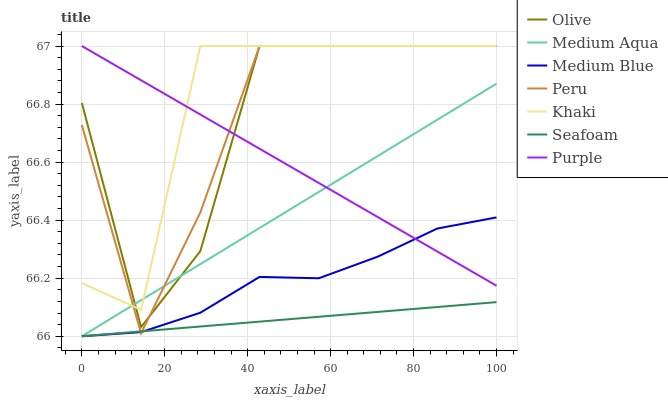Does Seafoam have the minimum area under the curve?
Answer yes or no. Yes. Does Khaki have the maximum area under the curve?
Answer yes or no. Yes. Does Purple have the minimum area under the curve?
Answer yes or no. No. Does Purple have the maximum area under the curve?
Answer yes or no. No. Is Seafoam the smoothest?
Answer yes or no. Yes. Is Olive the roughest?
Answer yes or no. Yes. Is Purple the smoothest?
Answer yes or no. No. Is Purple the roughest?
Answer yes or no. No. Does Medium Blue have the lowest value?
Answer yes or no. Yes. Does Purple have the lowest value?
Answer yes or no. No. Does Olive have the highest value?
Answer yes or no. Yes. Does Medium Blue have the highest value?
Answer yes or no. No. Is Medium Blue less than Khaki?
Answer yes or no. Yes. Is Olive greater than Medium Blue?
Answer yes or no. Yes. Does Medium Aqua intersect Olive?
Answer yes or no. Yes. Is Medium Aqua less than Olive?
Answer yes or no. No. Is Medium Aqua greater than Olive?
Answer yes or no. No. Does Medium Blue intersect Khaki?
Answer yes or no. No. 